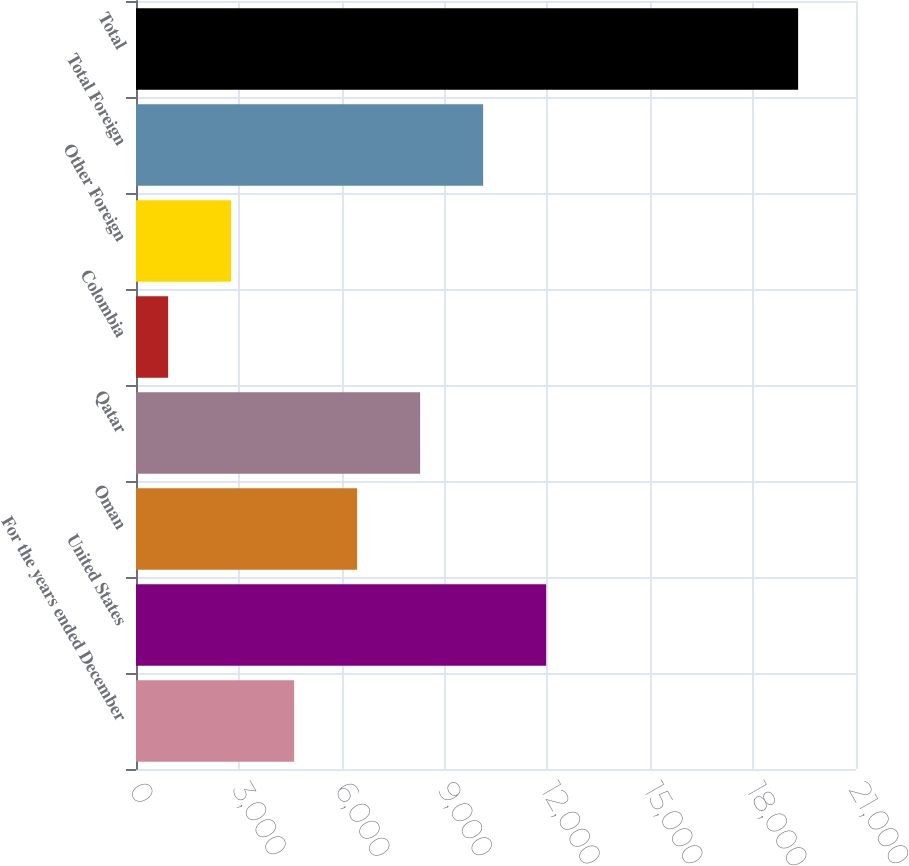Convert chart to OTSL. <chart><loc_0><loc_0><loc_500><loc_500><bar_chart><fcel>For the years ended December<fcel>United States<fcel>Oman<fcel>Qatar<fcel>Colombia<fcel>Other Foreign<fcel>Total Foreign<fcel>Total<nl><fcel>4612.8<fcel>11962.4<fcel>6450.2<fcel>8287.6<fcel>938<fcel>2775.4<fcel>10125<fcel>19312<nl></chart> 